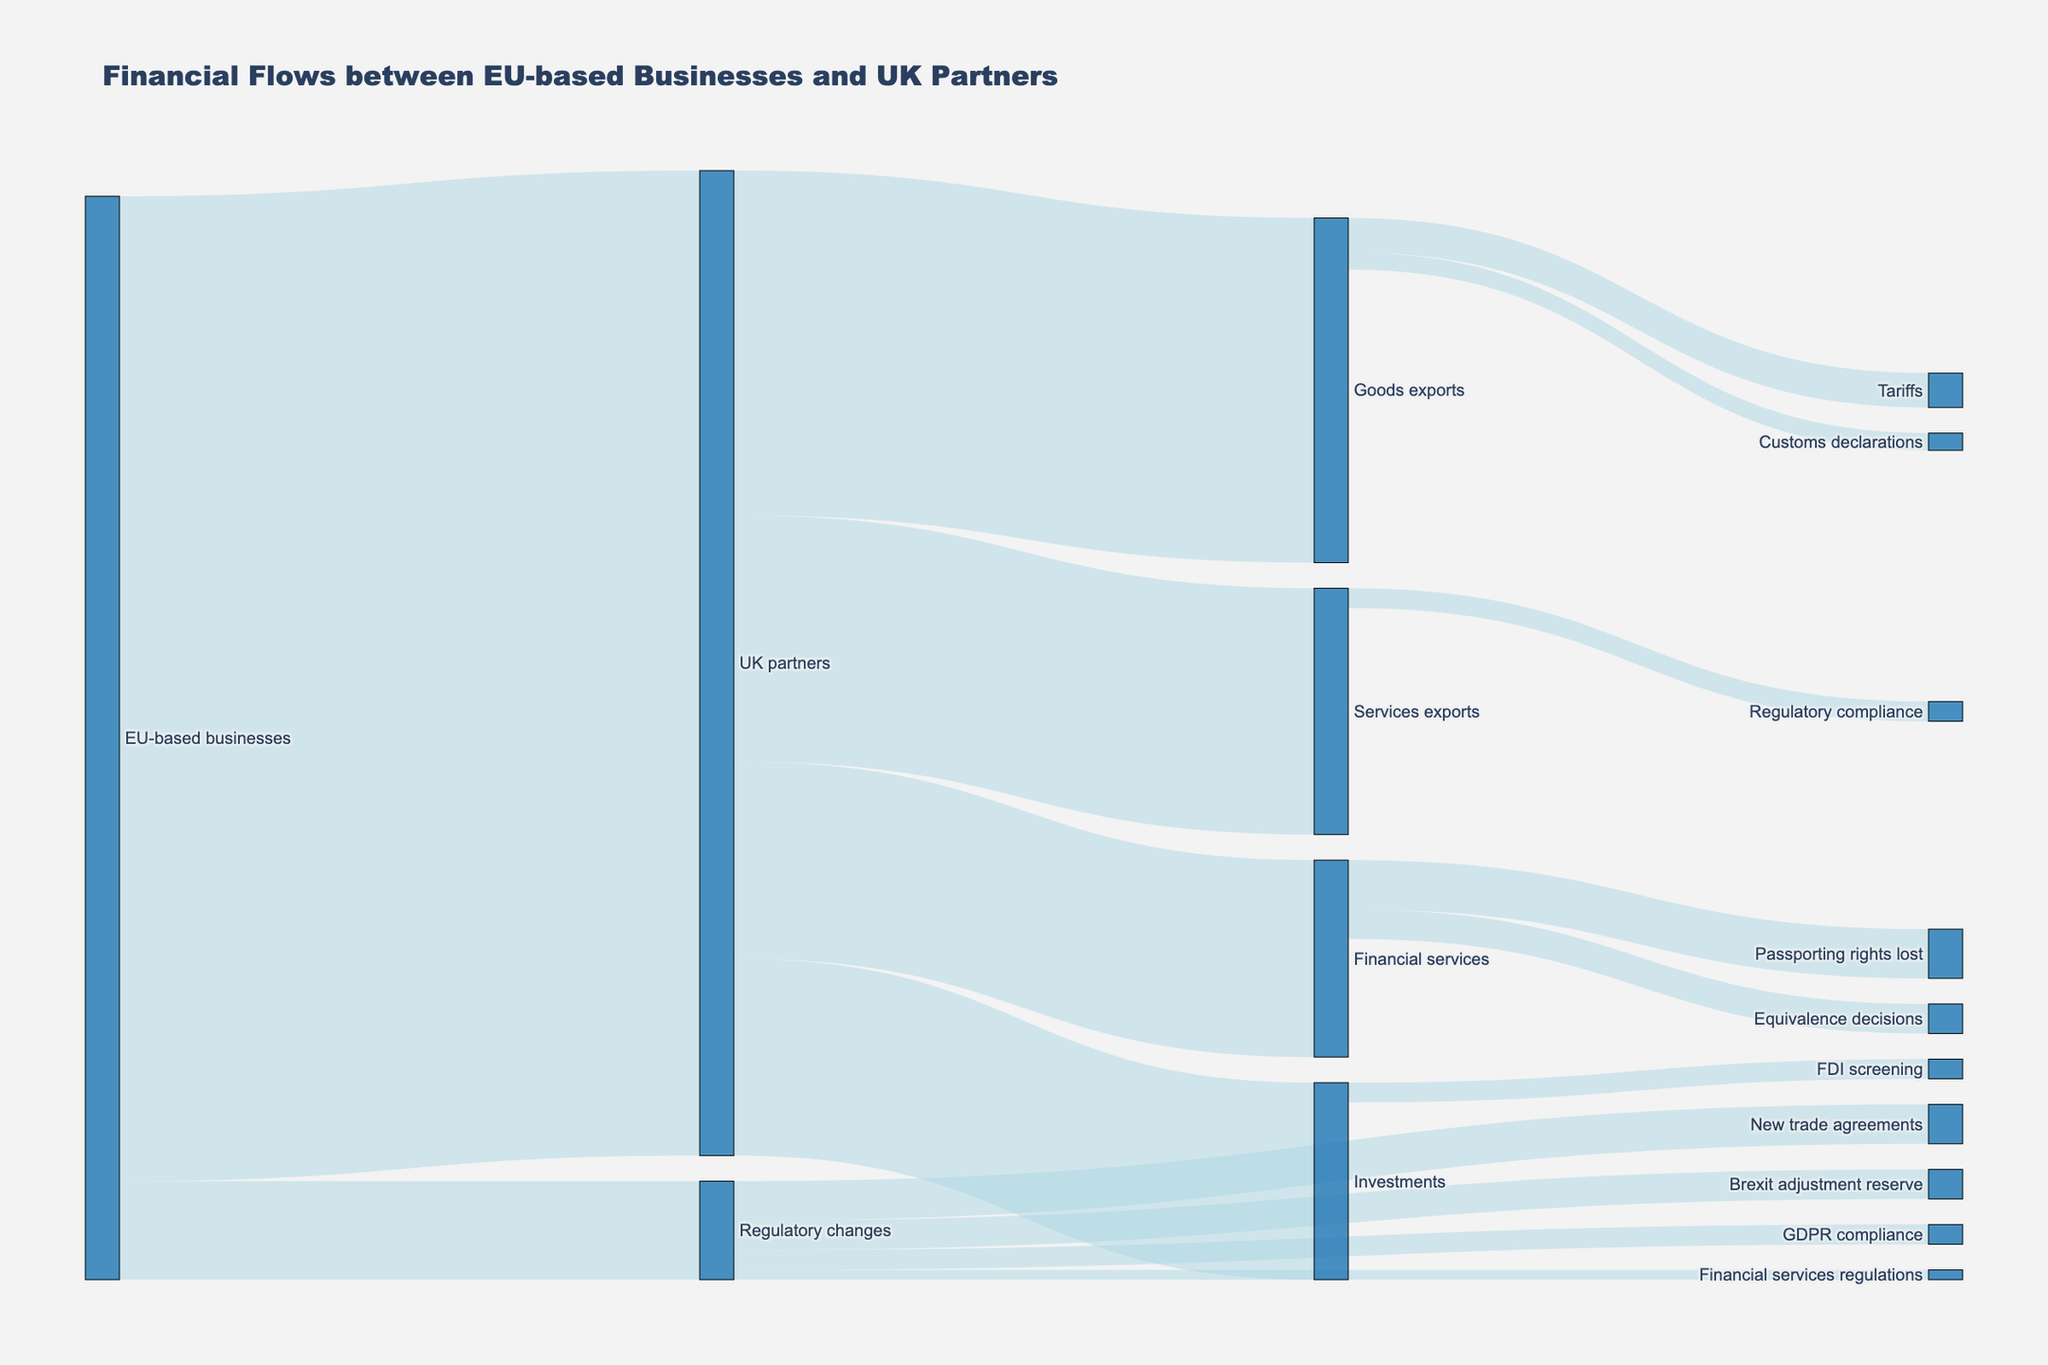What is the highest value financial flow in the diagram? Looking at the thickness and labels of the links, the flow from EU-based businesses to UK partners has the highest value of 100,000,000.
Answer: 100,000,000 How much financial flow is categorized under Regulatory changes? Sum the values moving towards Regulatory changes: New trade agreements (4,000,000), Brexit adjustment reserve (3,000,000), GDPR compliance (2,000,000), and Financial services regulations (1,000,000). So, 4,000,000 + 3,000,000 + 2,000,000 + 1,000,000 = 10,000,000.
Answer: 10,000,000 Which transaction type has the highest flow value from UK partners? The Goods exports from UK partners have the highest value of 35,000,000 compared to Services exports, Financial services, and Investments.
Answer: Goods exports Which regulatory change has the least financial flow associated with it? Of the flows under Regulatory changes, Financial services regulations have the least value, which is 1,000,000.
Answer: Financial services regulations How does the financial flow for Goods exports compare to Services exports? The value for Goods exports (35,000,000) is higher than that for Services exports (25,000,000).
Answer: Goods exports > Services exports What is the combined value of Goods exports and Financial services from UK partners? Add the values of Goods exports (35,000,000) and Financial services (20,000,000): 35,000,000 + 20,000,000 = 55,000,000.
Answer: 55,000,000 What is the total value associated with regulatory compliance for Goods, Services, and Financial services? Sum the values: Tariffs (35,000,000 * 0.1 = 3,500,000), Customs declarations (35,000,000 * 0.05 = 1,750,000), Regulatory compliance (2,000,000), Passporting rights lost (5,000,000), and Equivalence decisions (3,000,000). So, 3,500,000 + 1,750,000 + 2,000,000 + 5,000,000 + 3,000,000 = 15,250,000.
Answer: 15,250,000 What is the percentage contribution of Investments to the total flow from UK partners? The total flow from UK partners is 35,000,000 + 25,000,000 + 20,000,000 + 20,000,000 = 100,000,000. The Investments flow is 20,000,000. Therefore, the percentage is (20,000,000 / 100,000,000) * 100 = 20%.
Answer: 20% How much more is the financial flow from UK partners to Financial services compared to the Brexit adjustment reserve? The flow to Financial services is 20,000,000 and the Brexit adjustment reserve is 3,000,000. The difference is 20,000,000 - 3,000,000 = 17,000,000.
Answer: 17,000,000 